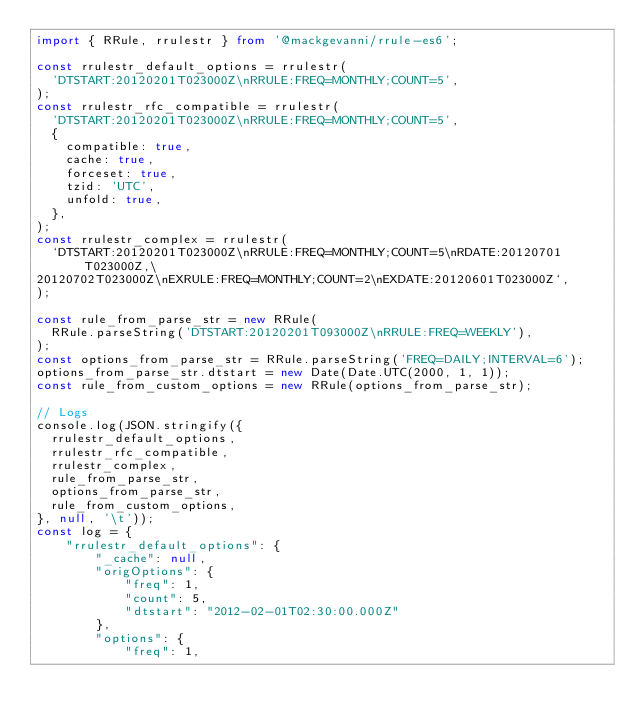<code> <loc_0><loc_0><loc_500><loc_500><_TypeScript_>import { RRule, rrulestr } from '@mackgevanni/rrule-es6';

const rrulestr_default_options = rrulestr(
  'DTSTART:20120201T023000Z\nRRULE:FREQ=MONTHLY;COUNT=5',
);
const rrulestr_rfc_compatible = rrulestr(
  'DTSTART:20120201T023000Z\nRRULE:FREQ=MONTHLY;COUNT=5',
  {
    compatible: true,
    cache: true,
    forceset: true,
    tzid: 'UTC',
    unfold: true,
  },
);
const rrulestr_complex = rrulestr(
  `DTSTART:20120201T023000Z\nRRULE:FREQ=MONTHLY;COUNT=5\nRDATE:20120701T023000Z,\
20120702T023000Z\nEXRULE:FREQ=MONTHLY;COUNT=2\nEXDATE:20120601T023000Z`,
);

const rule_from_parse_str = new RRule(
  RRule.parseString('DTSTART:20120201T093000Z\nRRULE:FREQ=WEEKLY'),
);
const options_from_parse_str = RRule.parseString('FREQ=DAILY;INTERVAL=6');
options_from_parse_str.dtstart = new Date(Date.UTC(2000, 1, 1));
const rule_from_custom_options = new RRule(options_from_parse_str);

// Logs
console.log(JSON.stringify({
  rrulestr_default_options,
  rrulestr_rfc_compatible,
  rrulestr_complex,
  rule_from_parse_str,
  options_from_parse_str,
  rule_from_custom_options,
}, null, '\t'));
const log = {
	"rrulestr_default_options": {
		"_cache": null,
		"origOptions": {
			"freq": 1,
			"count": 5,
			"dtstart": "2012-02-01T02:30:00.000Z"
		},
		"options": {
			"freq": 1,</code> 